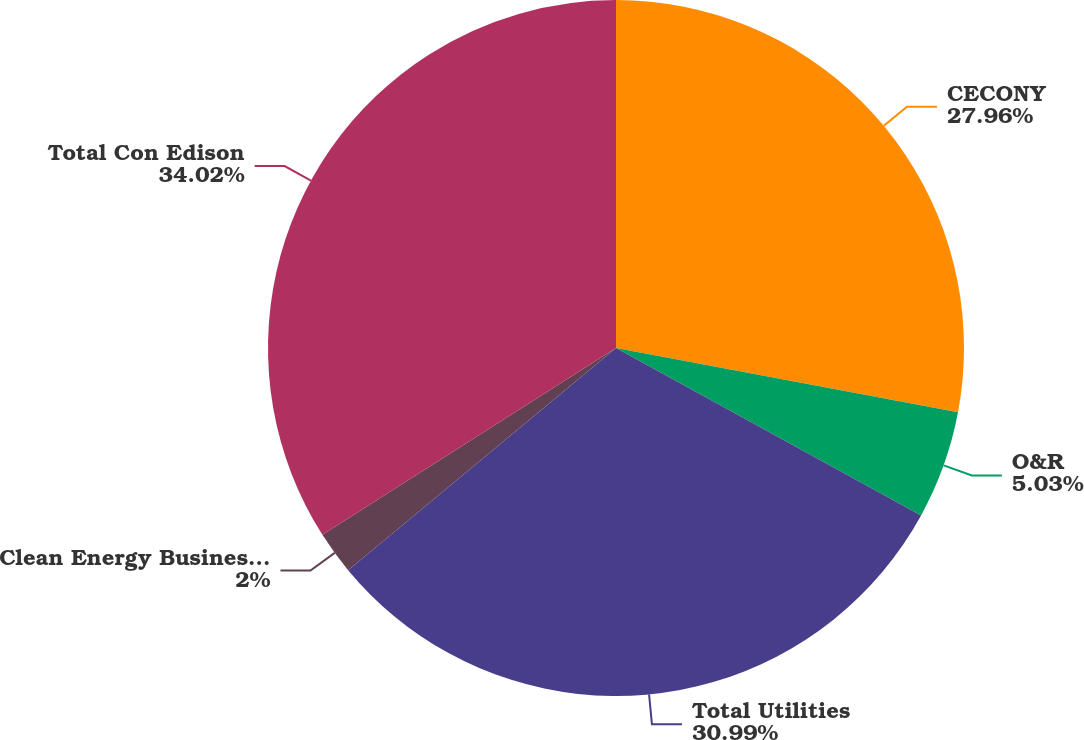Convert chart to OTSL. <chart><loc_0><loc_0><loc_500><loc_500><pie_chart><fcel>CECONY<fcel>O&R<fcel>Total Utilities<fcel>Clean Energy Businesses (a)<fcel>Total Con Edison<nl><fcel>27.96%<fcel>5.03%<fcel>30.99%<fcel>2.0%<fcel>34.02%<nl></chart> 